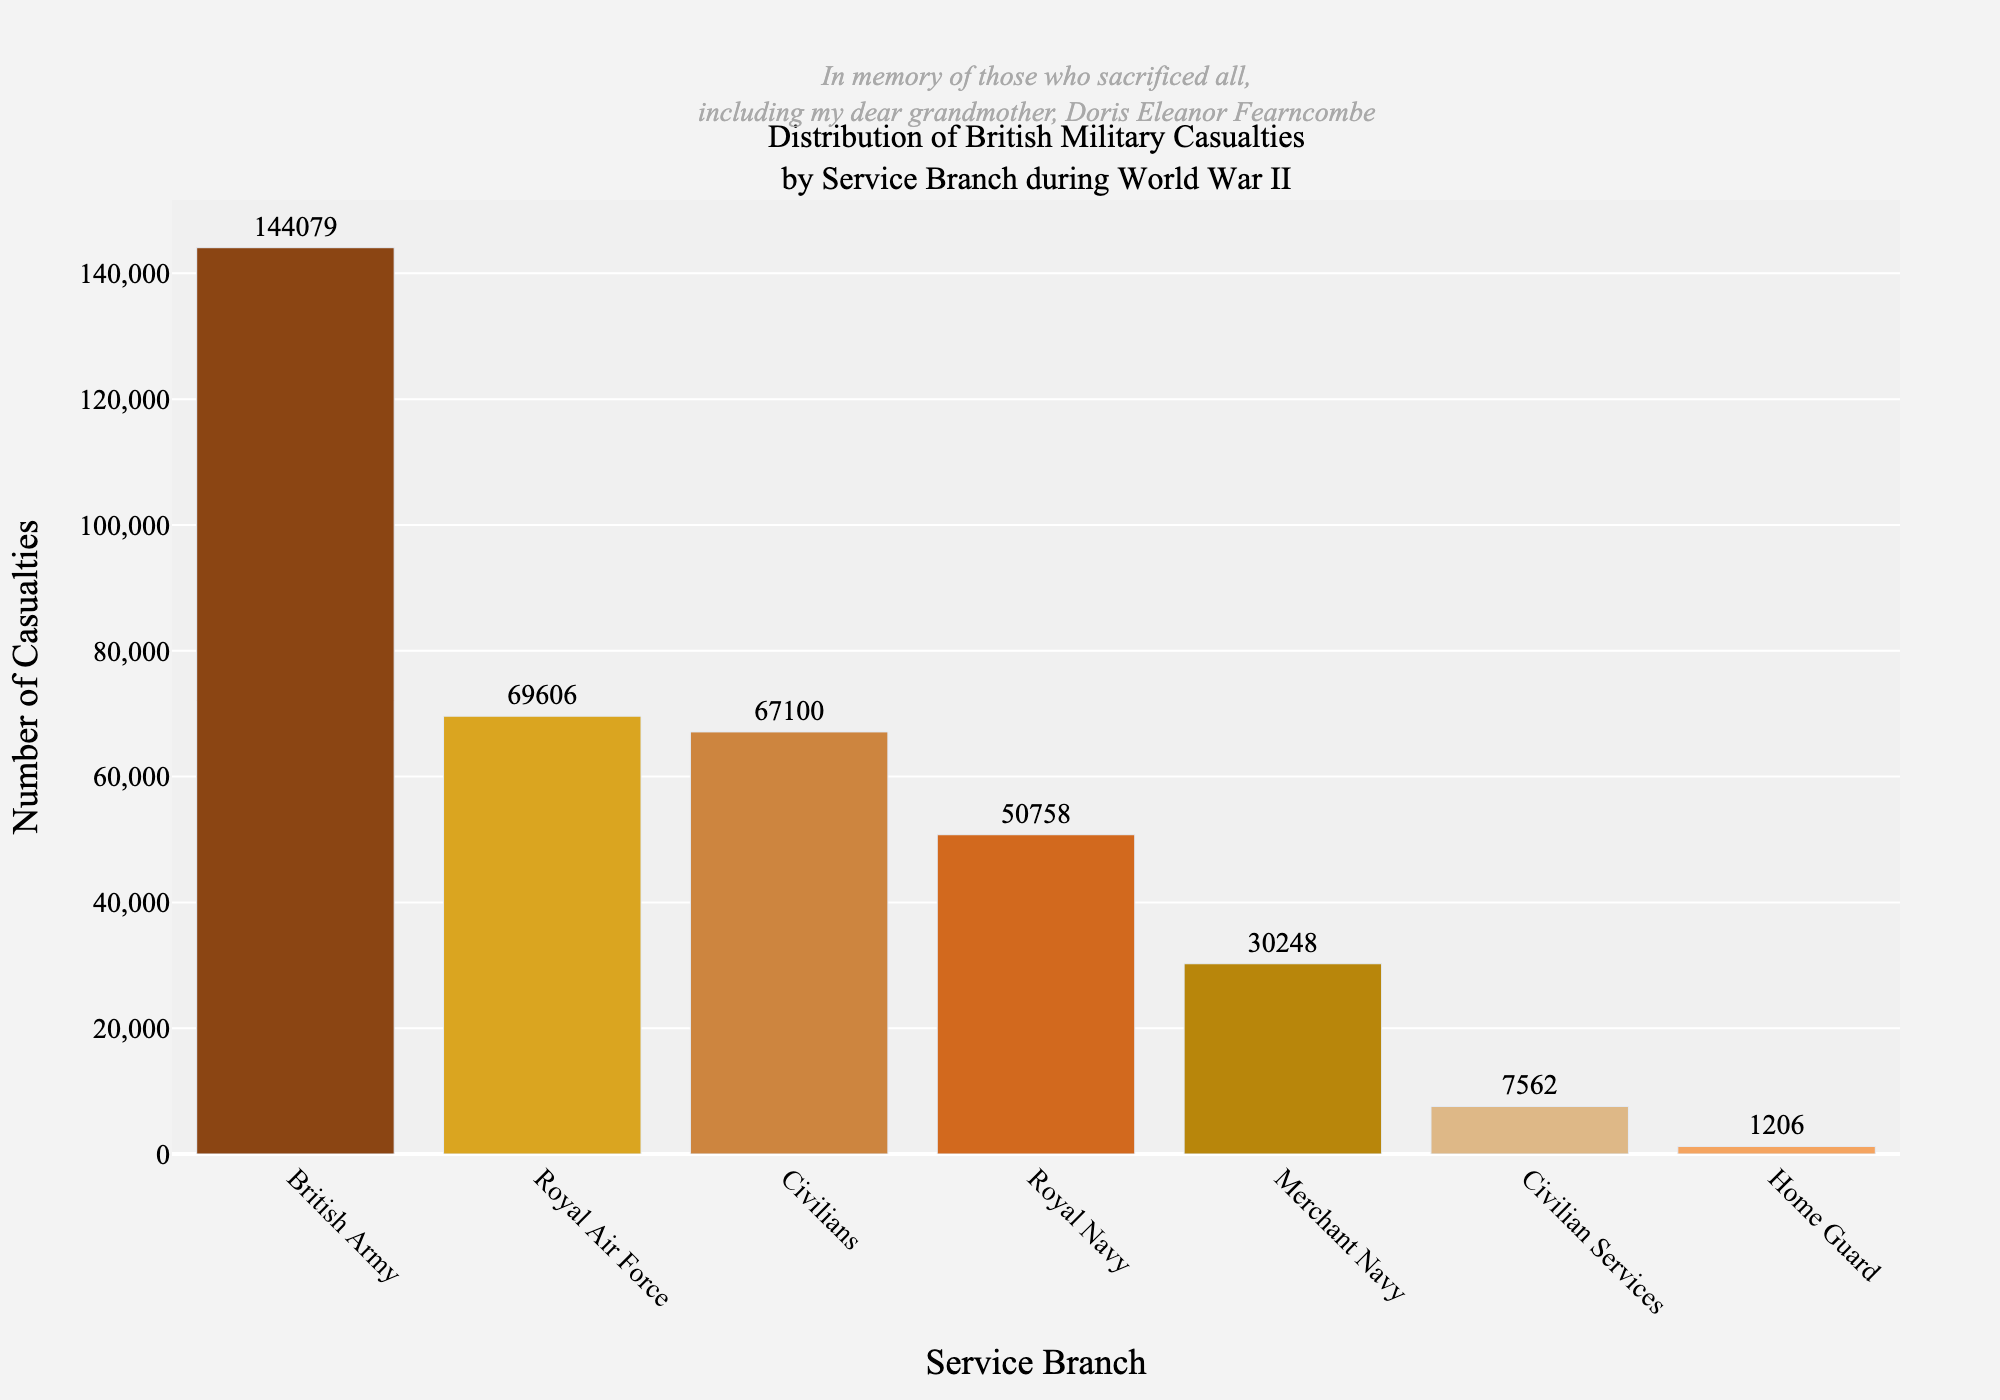What service branch had the highest number of casualties? From the bar chart, the British Army has the tallest bar indicating the highest number of casualties.
Answer: British Army Which service branch has approximately half the number of casualties as the British Army? The British Army has 144,079 casualties. The bar length nearest to half of this (~72,040) is that of the Royal Air Force with 69,606 casualties.
Answer: Royal Air Force What is the combined total of casualties for the Royal Navy and the Merchant Navy? Add the casualties from the Royal Navy (50,758) and the Merchant Navy (30,248): 50,758 + 30,248 = 81,006.
Answer: 81,006 Which service branches have fewer casualties than civilians? Civilians have 67,100 casualties. Bars shorter than this represent Royal Navy, Merchant Navy, Civilian Services, and Home Guard.
Answer: Royal Navy, Merchant Navy, Civilian Services, Home Guard By how much do casualties in the Royal Air Force exceed those in the Merchant Navy? Subtract the Merchant Navy (30,248 casualties) from the Royal Air Force (69,606 casualties): 69,606 - 30,248 = 39,358.
Answer: 39,358 What is the difference in casualties between the Home Guard and Civilian Services? Subtract Home Guard (1,206 casualties) from Civilian Services (7,562 casualties): 7,562 - 1,206 = 6,356.
Answer: 6,356 What percentage of total casualties is the Home Guard responsible for? Calculate the total casualties: 50,758 + 69,606 + 144,079 + 30,248 + 1,206 + 7,562 + 67,100 = 370,559. Then, (1,206 / 370,559) * 100 ≈ 0.325%.
Answer: 0.325% Which service branch's casualties form roughly one-fifth of the total casualties? One-fifth of total casualties (370,559) is 370,559 / 5 = 74,112. The closest branch to this number is Civilians with 67,100 casualties.
Answer: Civilians Are there more casualties in the Civilian Services or the Home Guard? Comparing the heights, Civilian Services had 7,562 casualties, which is higher than the Home Guard's 1,206 casualties.
Answer: Civilian Services What fraction of the total casualties does the British Army represent? Total casualties are 370,559. The British Army has 144,079 casualties. The fraction is 144,079 / 370,559 ≈ 0.389 or roughly 39%.
Answer: 0.389 or 39% 